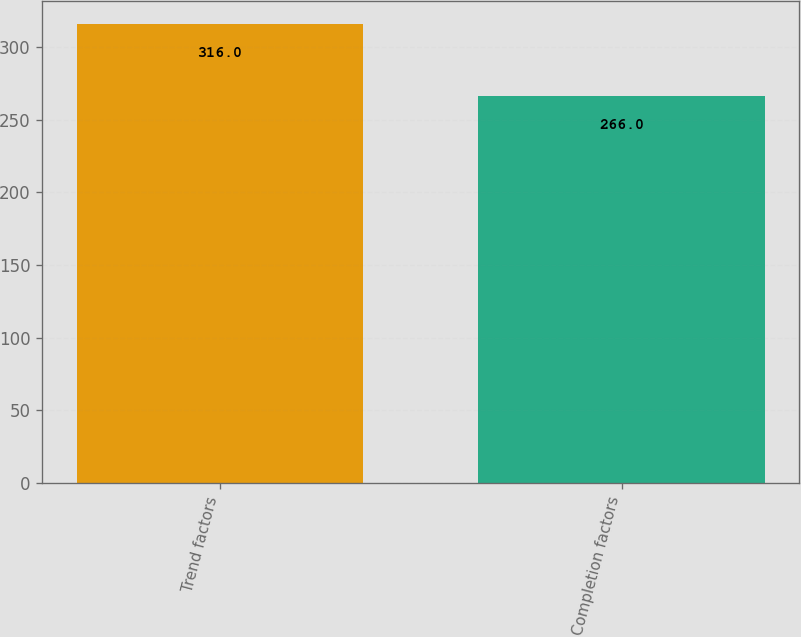Convert chart. <chart><loc_0><loc_0><loc_500><loc_500><bar_chart><fcel>Trend factors<fcel>Completion factors<nl><fcel>316<fcel>266<nl></chart> 